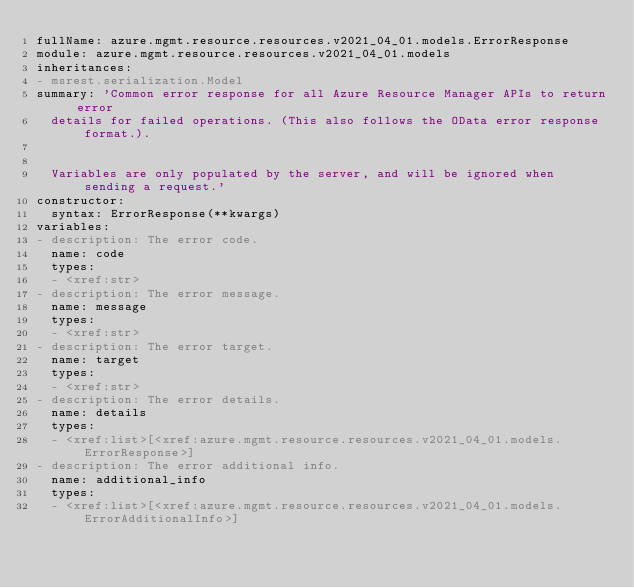Convert code to text. <code><loc_0><loc_0><loc_500><loc_500><_YAML_>fullName: azure.mgmt.resource.resources.v2021_04_01.models.ErrorResponse
module: azure.mgmt.resource.resources.v2021_04_01.models
inheritances:
- msrest.serialization.Model
summary: 'Common error response for all Azure Resource Manager APIs to return error
  details for failed operations. (This also follows the OData error response format.).


  Variables are only populated by the server, and will be ignored when sending a request.'
constructor:
  syntax: ErrorResponse(**kwargs)
variables:
- description: The error code.
  name: code
  types:
  - <xref:str>
- description: The error message.
  name: message
  types:
  - <xref:str>
- description: The error target.
  name: target
  types:
  - <xref:str>
- description: The error details.
  name: details
  types:
  - <xref:list>[<xref:azure.mgmt.resource.resources.v2021_04_01.models.ErrorResponse>]
- description: The error additional info.
  name: additional_info
  types:
  - <xref:list>[<xref:azure.mgmt.resource.resources.v2021_04_01.models.ErrorAdditionalInfo>]
</code> 